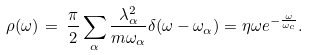Convert formula to latex. <formula><loc_0><loc_0><loc_500><loc_500>\rho ( \omega ) \, = \, \frac { \pi } { 2 } \sum _ { \alpha } \frac { \lambda ^ { 2 } _ { \alpha } } { m \omega _ { \alpha } } { \delta ( \omega - \omega _ { \alpha } ) } = \eta \omega { e ^ { - { \frac { \omega } { \omega _ { c } } } } } .</formula> 